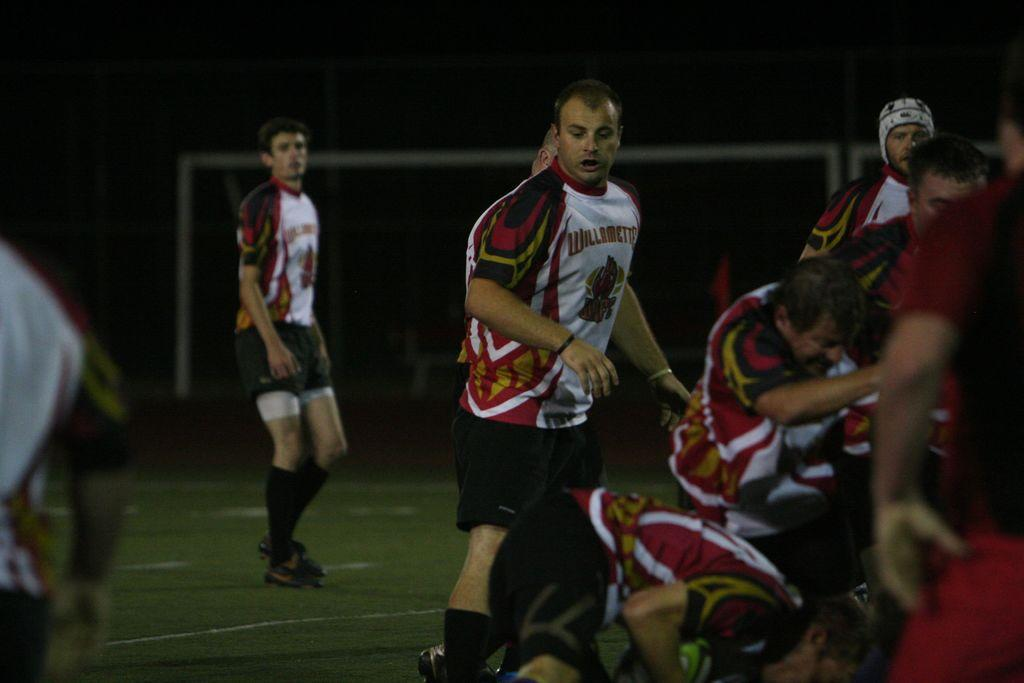<image>
Provide a brief description of the given image. The soccer players wearing maroon and white play for Willamette University. 